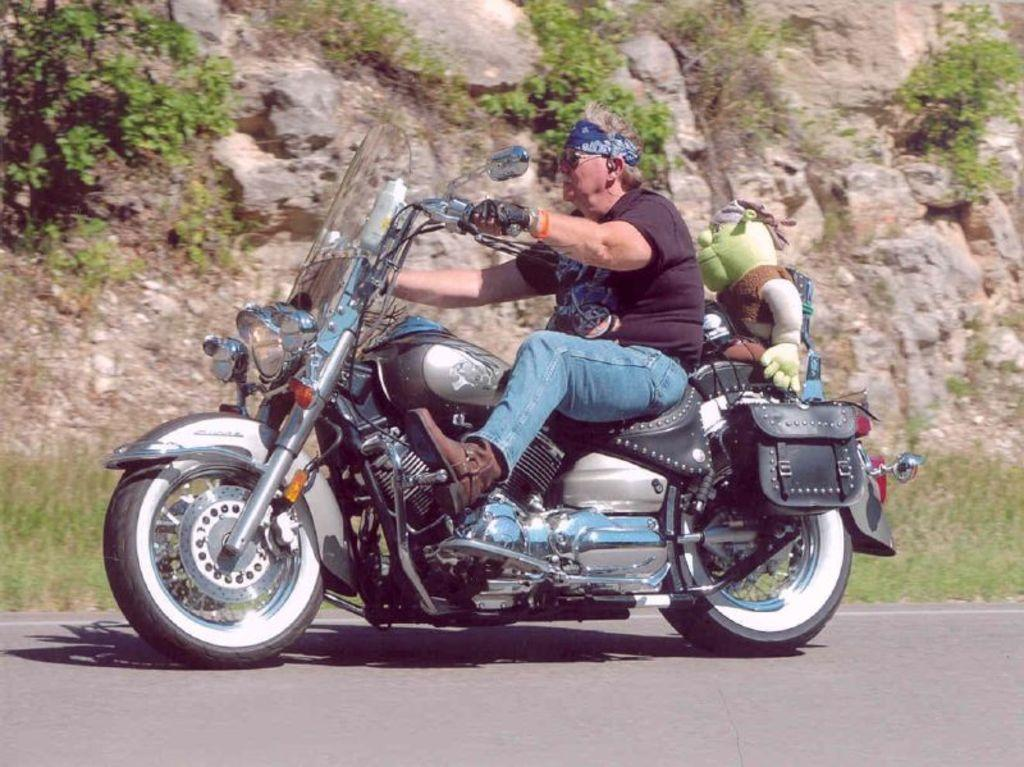What type of natural elements can be seen in the image? There are stones, plants, and grass in the image. What is the man in the image doing? The man is riding a bike in the image. What object is sitting beside the man? There is a doll sitting beside the man. What type of path is visible in the image? There is a road in the image. What type of rod can be seen in the image? There is no rod present in the image. Is there a bathtub visible in the image? No, there is no bathtub present in the image. 